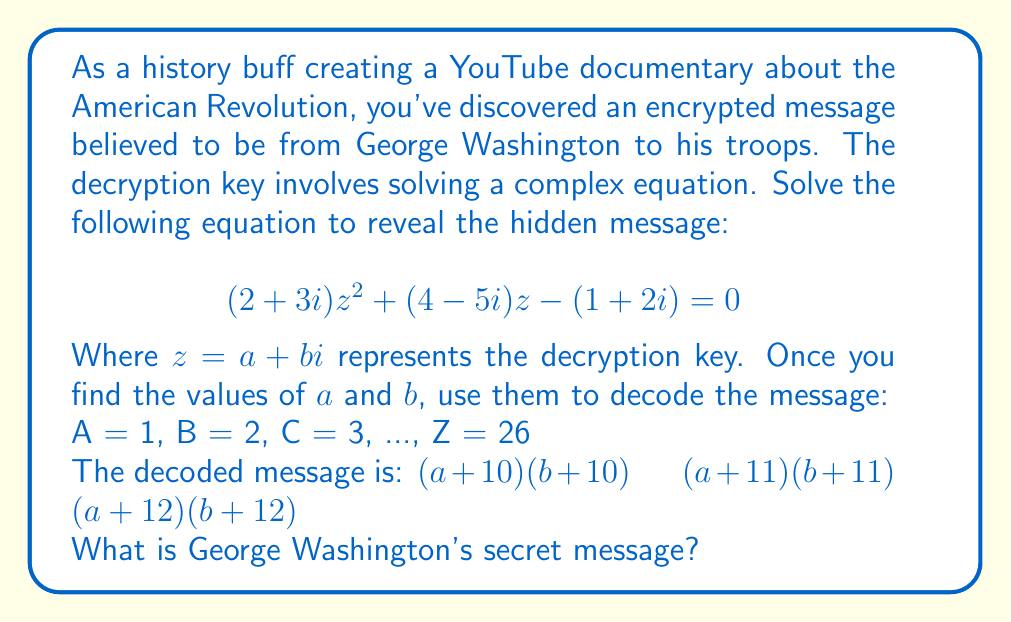Can you solve this math problem? To solve this problem, we need to follow these steps:

1) First, let's solve the quadratic equation in complex form:
   $$(2+3i)z^2 + (4-5i)z - (1+2i) = 0$$

2) We can use the quadratic formula: $z = \frac{-b \pm \sqrt{b^2-4ac}}{2a}$

   Where $a = 2+3i$, $b = 4-5i$, and $c = -(1+2i)$

3) Let's calculate the discriminant $b^2-4ac$:
   
   $b^2 = (4-5i)^2 = 16 - 40i + 25i^2 = -9-40i$
   
   $4ac = 4(2+3i)(-(1+2i)) = -8-16i-12i+24 = 16-28i$
   
   $b^2-4ac = (-9-40i) - (16-28i) = -25-12i$

4) Now, let's calculate $\sqrt{b^2-4ac}$:
   
   $\sqrt{-25-12i} = 4-3i$ (you can verify this by squaring)

5) Plugging everything into the quadratic formula:

   $z = \frac{-(4-5i) \pm (4-3i)}{2(2+3i)}$

6) Let's choose the '+' solution:

   $z = \frac{-4+5i + 4-3i}{4+6i} = \frac{2i}{4+6i}$

7) To simplify this, multiply numerator and denominator by the complex conjugate of the denominator:

   $z = \frac{2i}{4+6i} \cdot \frac{4-6i}{4-6i} = \frac{8i+12}{16+36} = \frac{8i+12}{52} = \frac{4i+6}{26} = \frac{2i+3}{13}$

8) Therefore, $a = \frac{3}{13}$ and $b = \frac{2}{13}$

9) Now, let's decode the message:
   
   $(\frac{3}{13}+10)(\frac{2}{13}+10) = 10 \cdot 10 = 100 = \text{J}$
   
   $(\frac{3}{13}+11)(\frac{2}{13}+11) = 11 \cdot 11 = 121 = \text{U}$
   
   $(\frac{3}{13}+12)(\frac{2}{13}+12) = 12 \cdot 12 = 144 = \text{N}$

Therefore, the decoded message is "JUN", which likely stands for "JUNE".
Answer: JUNE 